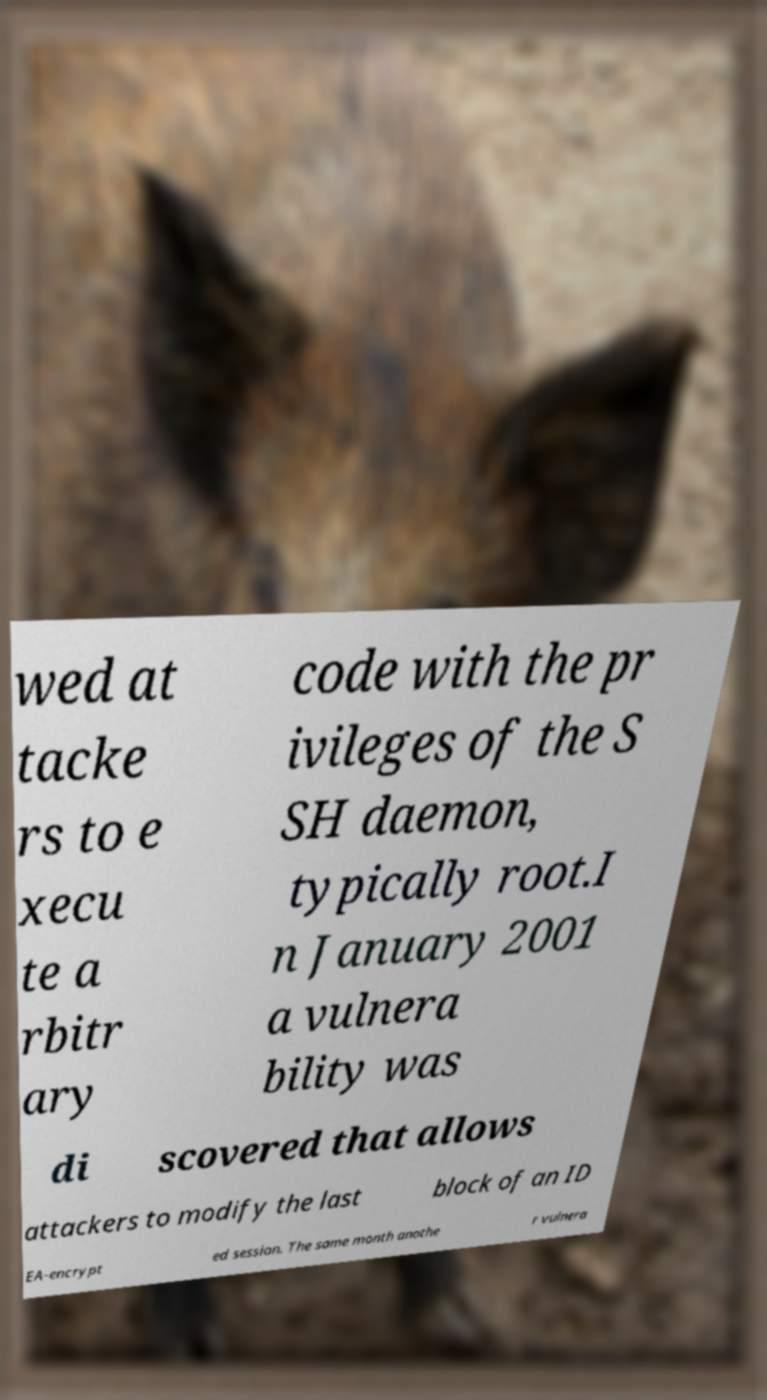Please read and relay the text visible in this image. What does it say? wed at tacke rs to e xecu te a rbitr ary code with the pr ivileges of the S SH daemon, typically root.I n January 2001 a vulnera bility was di scovered that allows attackers to modify the last block of an ID EA-encrypt ed session. The same month anothe r vulnera 